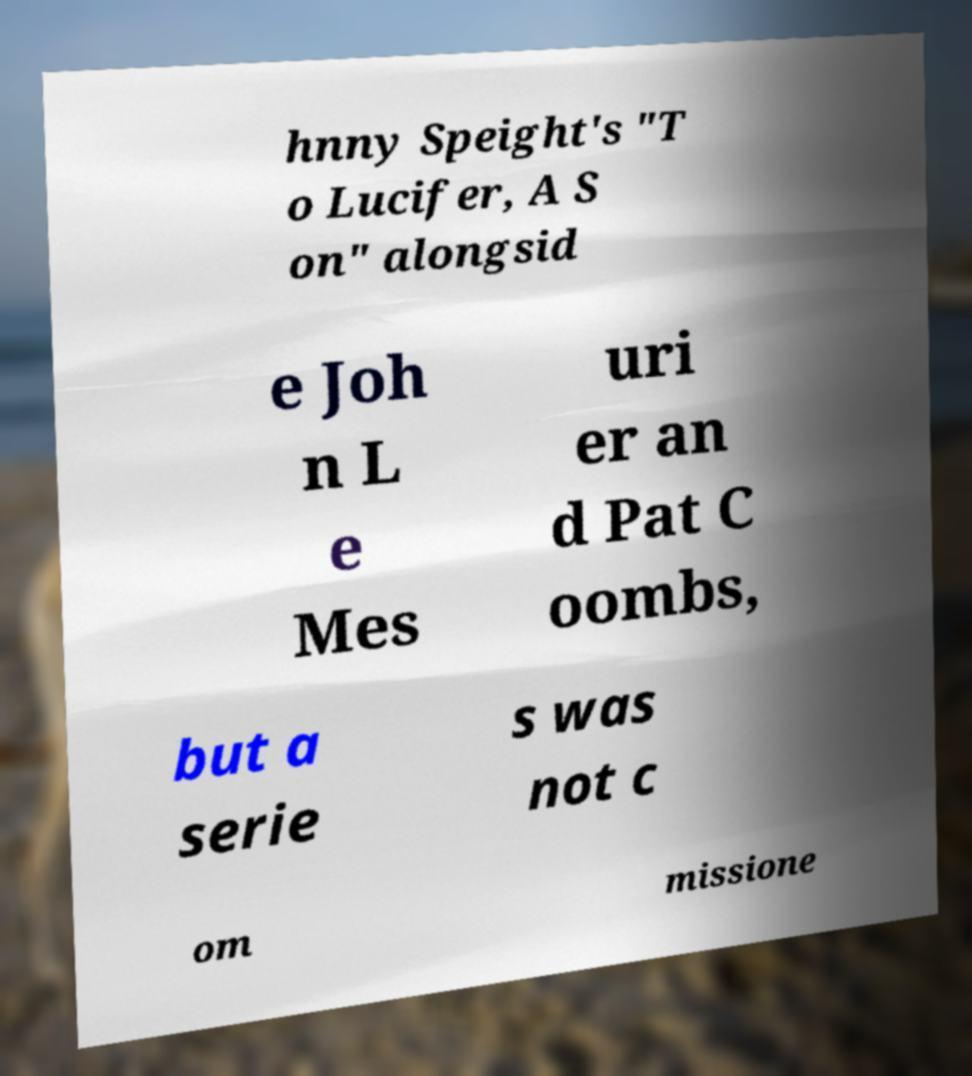Please identify and transcribe the text found in this image. hnny Speight's "T o Lucifer, A S on" alongsid e Joh n L e Mes uri er an d Pat C oombs, but a serie s was not c om missione 